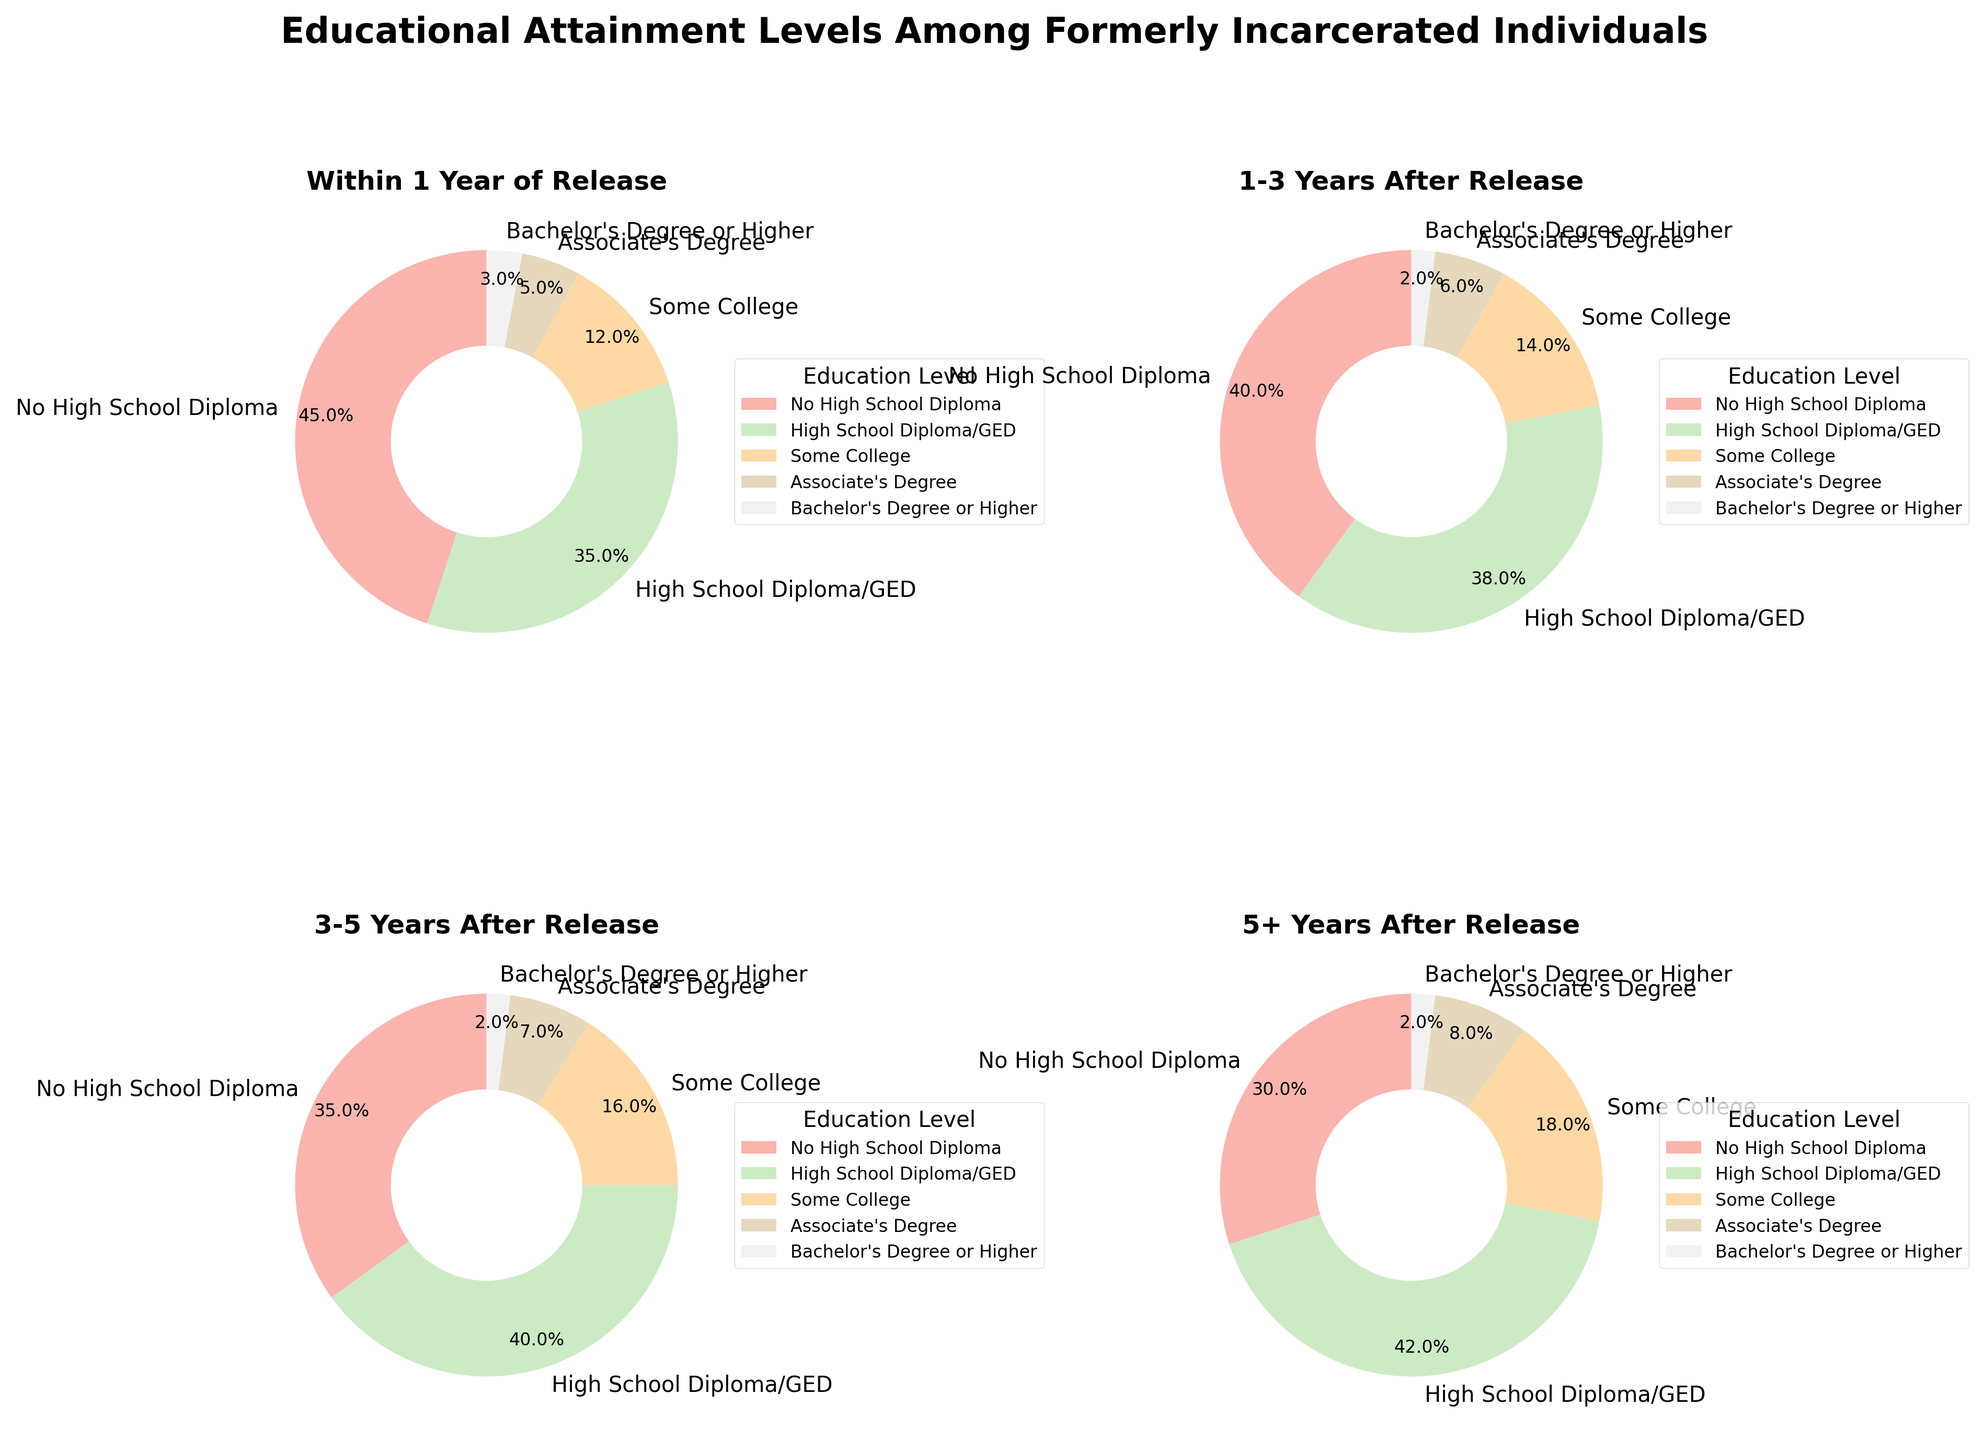What is the largest category within 1 Year of Release? Looking at the pie chart for "Within 1 Year of Release," the section labeled "No High School Diploma" is the largest, taking up 45% of the pie chart.
Answer: No High School Diploma How does the percentage of individuals with an Associate's Degree change from within 1 Year of Release to 5+ Years After Release? Comparing the two categories: within 1 Year of Release shows 5% while 5+ Years After Release shows 8%. The change is 3 percentage points.
Answer: Increases by 3% Which educational attainment category has the smallest percentage in all time frames post-release? Reviewing all the pie charts, "Bachelor's Degree or Higher" consistently has the smallest percentage across all time frames, ranging from 2% to 3%.
Answer: Bachelor's Degree or Higher What is the total percentage of individuals with at least some college education 3-5 Years After Release? Adding the percentages for "Some College," "Associate's Degree," and "Bachelor's Degree or Higher" in the 3-5 Years After Release chart: 16% + 7% + 2% = 25%.
Answer: 25% Which category shows the largest increase in the percentage of individuals holding a High School Diploma/GED from within 1 Year of Release to 5+ Years After Release? The "High School Diploma/GED" category increases from 35% within 1 Year of Release to 42% in 5+ Years After Release, which is the largest increase observed.
Answer: High School Diploma/GED What is the approximate overall trend in the percentage of individuals with "No High School Diploma" over time after release? The "No High School Diploma" category decreases over time: from 45% within 1 Year of Release to 30% in 5+ Years After Release.
Answer: Decreasing How does the percentage of individuals with "Some College" education change between 1-3 Years After Release to 3-5 Years After Release? The percentage for "Some College" is 14% in 1-3 Years After Release and 16% in 3-5 Years After Release, meaning it increases by 2 percentage points.
Answer: Increases by 2% Which educational level shows the least variation in percentage across all time frames? "Bachelor's Degree or Higher" shows minimal variation, fluctuating only between 2% and 3%.
Answer: Bachelor's Degree or Higher At what time frame post-release do individuals with a High School Diploma/GED make up the highest percentage? According to the pie charts, individuals with a High School Diploma/GED make up the highest percentage (42%) 5+ Years After Release.
Answer: 5+ Years After Release What's the difference between the percentage of individuals with at least a High School Diploma (including GED) and those with "No High School Diploma" 1-3 Years After Release? Summing up the percentages for High School Diploma/GED, Some College, Associate's Degree, and Bachelor's Degree or Higher in the 1-3 Years After Release chart: 38% + 14% + 6% + 2% = 60%. The difference from "No High School Diploma" (40%) is 60% - 40% = 20 percentage points.
Answer: 20% 